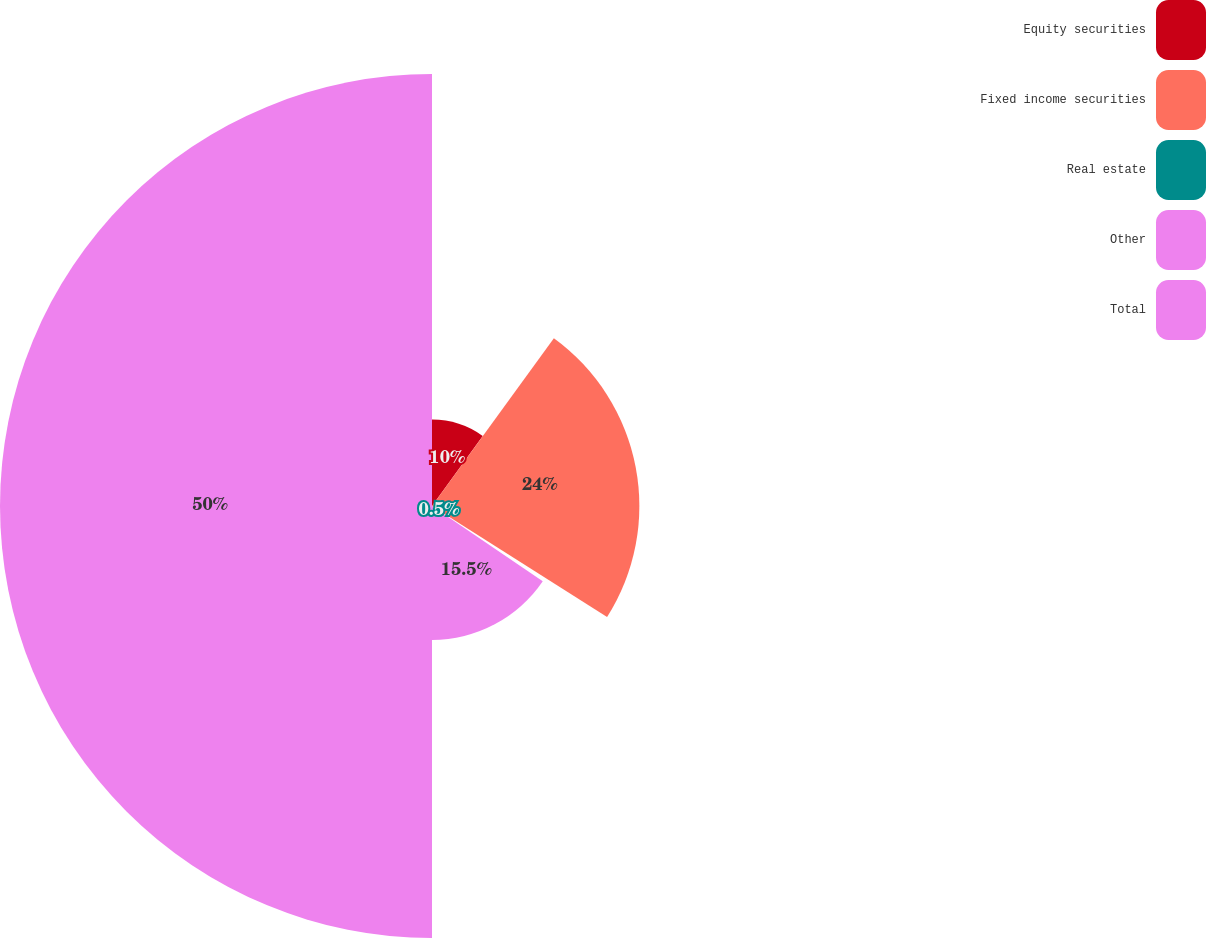Convert chart to OTSL. <chart><loc_0><loc_0><loc_500><loc_500><pie_chart><fcel>Equity securities<fcel>Fixed income securities<fcel>Real estate<fcel>Other<fcel>Total<nl><fcel>10.0%<fcel>24.0%<fcel>0.5%<fcel>15.5%<fcel>50.0%<nl></chart> 